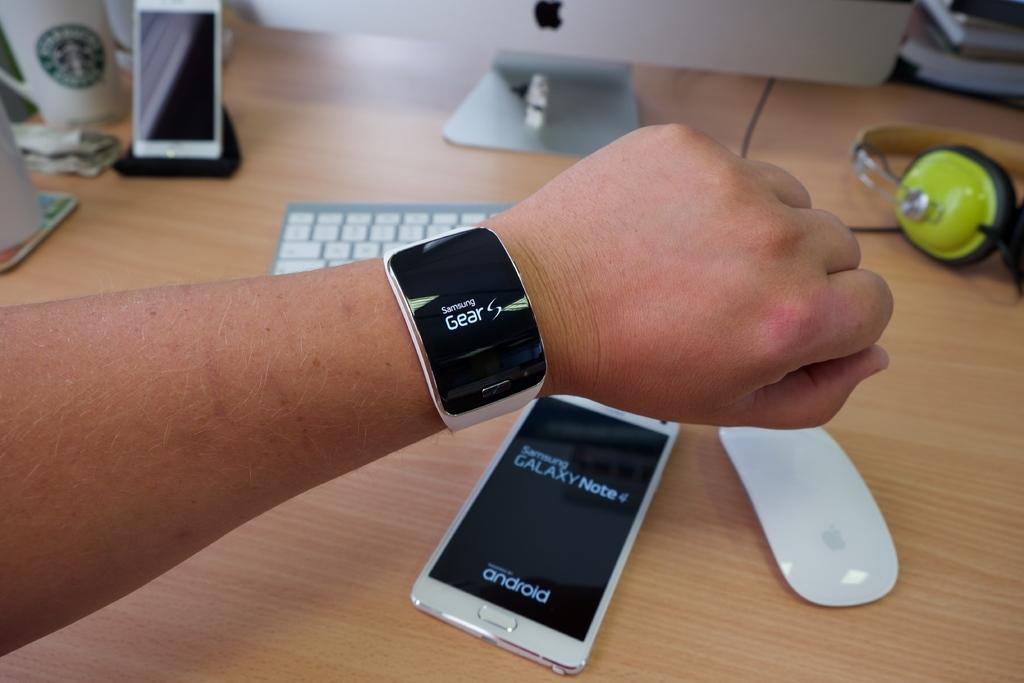<image>
Create a compact narrative representing the image presented. A Samsung Gear watch and a Samung Galaxy phone are near a keyboard. 